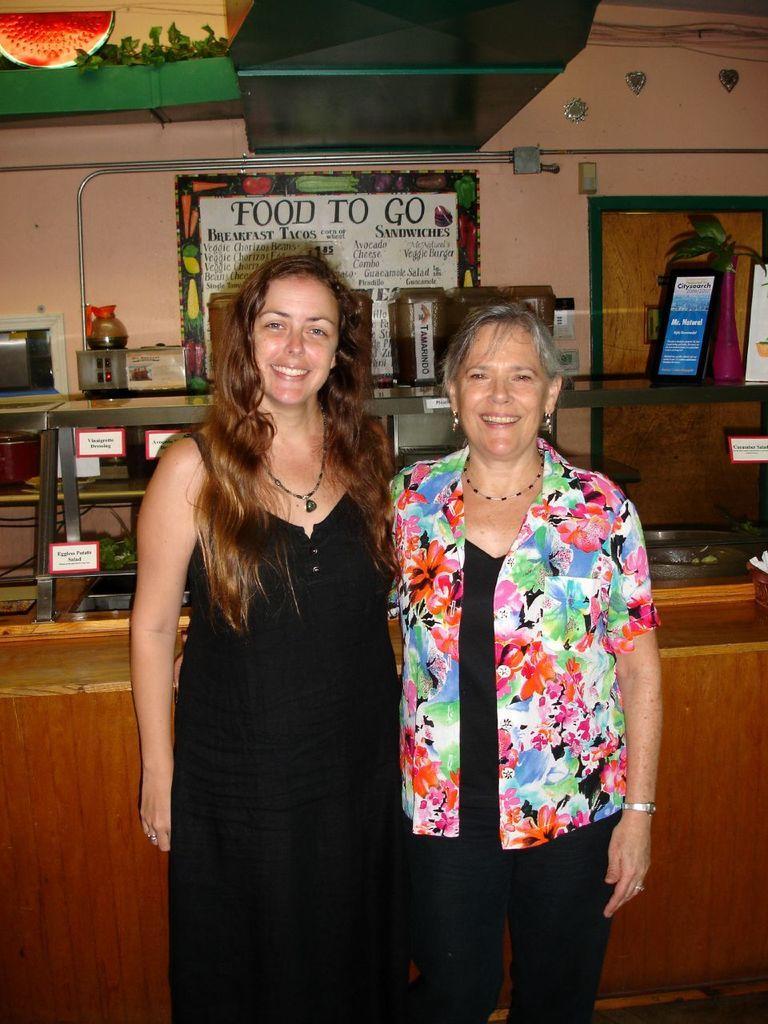Describe this image in one or two sentences. In this image I can see two people with different color dresses. In the background I can see many boards on the food stall. I can also see some boards to the wall. 